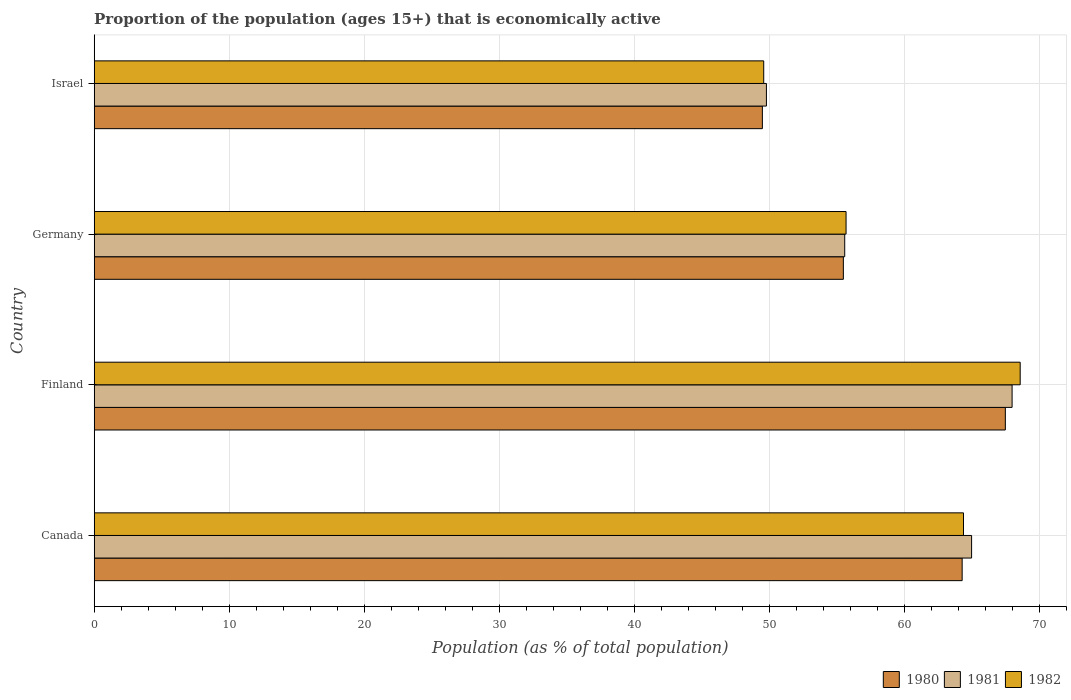How many groups of bars are there?
Your answer should be very brief. 4. How many bars are there on the 4th tick from the top?
Your answer should be compact. 3. How many bars are there on the 1st tick from the bottom?
Your answer should be compact. 3. What is the label of the 1st group of bars from the top?
Provide a succinct answer. Israel. What is the proportion of the population that is economically active in 1981 in Canada?
Ensure brevity in your answer.  65. Across all countries, what is the maximum proportion of the population that is economically active in 1980?
Keep it short and to the point. 67.5. Across all countries, what is the minimum proportion of the population that is economically active in 1980?
Your answer should be compact. 49.5. In which country was the proportion of the population that is economically active in 1982 maximum?
Your answer should be very brief. Finland. In which country was the proportion of the population that is economically active in 1981 minimum?
Your answer should be compact. Israel. What is the total proportion of the population that is economically active in 1980 in the graph?
Make the answer very short. 236.8. What is the difference between the proportion of the population that is economically active in 1982 in Canada and that in Germany?
Offer a terse response. 8.7. What is the difference between the proportion of the population that is economically active in 1982 in Germany and the proportion of the population that is economically active in 1980 in Finland?
Ensure brevity in your answer.  -11.8. What is the average proportion of the population that is economically active in 1982 per country?
Provide a short and direct response. 59.57. What is the difference between the proportion of the population that is economically active in 1981 and proportion of the population that is economically active in 1980 in Israel?
Your answer should be compact. 0.3. In how many countries, is the proportion of the population that is economically active in 1982 greater than 12 %?
Provide a succinct answer. 4. What is the ratio of the proportion of the population that is economically active in 1982 in Finland to that in Germany?
Keep it short and to the point. 1.23. Is the proportion of the population that is economically active in 1980 in Finland less than that in Israel?
Offer a very short reply. No. Is the difference between the proportion of the population that is economically active in 1981 in Finland and Germany greater than the difference between the proportion of the population that is economically active in 1980 in Finland and Germany?
Give a very brief answer. Yes. What is the difference between the highest and the second highest proportion of the population that is economically active in 1980?
Your answer should be compact. 3.2. Is the sum of the proportion of the population that is economically active in 1981 in Finland and Germany greater than the maximum proportion of the population that is economically active in 1982 across all countries?
Provide a short and direct response. Yes. What does the 1st bar from the top in Germany represents?
Give a very brief answer. 1982. What does the 2nd bar from the bottom in Canada represents?
Offer a very short reply. 1981. Are all the bars in the graph horizontal?
Offer a very short reply. Yes. Are the values on the major ticks of X-axis written in scientific E-notation?
Your answer should be very brief. No. Does the graph contain any zero values?
Make the answer very short. No. Does the graph contain grids?
Your answer should be very brief. Yes. Where does the legend appear in the graph?
Ensure brevity in your answer.  Bottom right. What is the title of the graph?
Offer a terse response. Proportion of the population (ages 15+) that is economically active. What is the label or title of the X-axis?
Provide a succinct answer. Population (as % of total population). What is the Population (as % of total population) of 1980 in Canada?
Make the answer very short. 64.3. What is the Population (as % of total population) in 1981 in Canada?
Provide a succinct answer. 65. What is the Population (as % of total population) in 1982 in Canada?
Your answer should be very brief. 64.4. What is the Population (as % of total population) of 1980 in Finland?
Your response must be concise. 67.5. What is the Population (as % of total population) of 1981 in Finland?
Make the answer very short. 68. What is the Population (as % of total population) in 1982 in Finland?
Your answer should be very brief. 68.6. What is the Population (as % of total population) of 1980 in Germany?
Your answer should be compact. 55.5. What is the Population (as % of total population) in 1981 in Germany?
Your answer should be compact. 55.6. What is the Population (as % of total population) of 1982 in Germany?
Keep it short and to the point. 55.7. What is the Population (as % of total population) in 1980 in Israel?
Offer a very short reply. 49.5. What is the Population (as % of total population) of 1981 in Israel?
Offer a very short reply. 49.8. What is the Population (as % of total population) in 1982 in Israel?
Your answer should be very brief. 49.6. Across all countries, what is the maximum Population (as % of total population) of 1980?
Offer a terse response. 67.5. Across all countries, what is the maximum Population (as % of total population) in 1981?
Offer a terse response. 68. Across all countries, what is the maximum Population (as % of total population) in 1982?
Give a very brief answer. 68.6. Across all countries, what is the minimum Population (as % of total population) of 1980?
Offer a terse response. 49.5. Across all countries, what is the minimum Population (as % of total population) of 1981?
Your response must be concise. 49.8. Across all countries, what is the minimum Population (as % of total population) of 1982?
Offer a very short reply. 49.6. What is the total Population (as % of total population) in 1980 in the graph?
Offer a very short reply. 236.8. What is the total Population (as % of total population) of 1981 in the graph?
Provide a succinct answer. 238.4. What is the total Population (as % of total population) of 1982 in the graph?
Your answer should be compact. 238.3. What is the difference between the Population (as % of total population) of 1981 in Canada and that in Finland?
Offer a terse response. -3. What is the difference between the Population (as % of total population) of 1981 in Canada and that in Germany?
Offer a very short reply. 9.4. What is the difference between the Population (as % of total population) of 1980 in Canada and that in Israel?
Provide a succinct answer. 14.8. What is the difference between the Population (as % of total population) in 1981 in Canada and that in Israel?
Offer a very short reply. 15.2. What is the difference between the Population (as % of total population) of 1982 in Finland and that in Germany?
Your answer should be very brief. 12.9. What is the difference between the Population (as % of total population) of 1981 in Finland and that in Israel?
Offer a terse response. 18.2. What is the difference between the Population (as % of total population) of 1980 in Germany and that in Israel?
Make the answer very short. 6. What is the difference between the Population (as % of total population) of 1981 in Germany and that in Israel?
Offer a terse response. 5.8. What is the difference between the Population (as % of total population) of 1980 in Canada and the Population (as % of total population) of 1981 in Finland?
Offer a terse response. -3.7. What is the difference between the Population (as % of total population) in 1980 in Canada and the Population (as % of total population) in 1981 in Germany?
Ensure brevity in your answer.  8.7. What is the difference between the Population (as % of total population) of 1981 in Canada and the Population (as % of total population) of 1982 in Germany?
Keep it short and to the point. 9.3. What is the difference between the Population (as % of total population) in 1980 in Canada and the Population (as % of total population) in 1981 in Israel?
Offer a very short reply. 14.5. What is the difference between the Population (as % of total population) in 1980 in Canada and the Population (as % of total population) in 1982 in Israel?
Keep it short and to the point. 14.7. What is the difference between the Population (as % of total population) of 1981 in Canada and the Population (as % of total population) of 1982 in Israel?
Offer a terse response. 15.4. What is the difference between the Population (as % of total population) of 1980 in Finland and the Population (as % of total population) of 1981 in Germany?
Make the answer very short. 11.9. What is the difference between the Population (as % of total population) of 1980 in Finland and the Population (as % of total population) of 1982 in Germany?
Ensure brevity in your answer.  11.8. What is the difference between the Population (as % of total population) of 1981 in Finland and the Population (as % of total population) of 1982 in Germany?
Offer a terse response. 12.3. What is the difference between the Population (as % of total population) of 1981 in Finland and the Population (as % of total population) of 1982 in Israel?
Your answer should be very brief. 18.4. What is the difference between the Population (as % of total population) in 1980 in Germany and the Population (as % of total population) in 1982 in Israel?
Offer a very short reply. 5.9. What is the difference between the Population (as % of total population) in 1981 in Germany and the Population (as % of total population) in 1982 in Israel?
Offer a terse response. 6. What is the average Population (as % of total population) of 1980 per country?
Provide a succinct answer. 59.2. What is the average Population (as % of total population) of 1981 per country?
Your answer should be compact. 59.6. What is the average Population (as % of total population) of 1982 per country?
Provide a short and direct response. 59.58. What is the difference between the Population (as % of total population) of 1980 and Population (as % of total population) of 1982 in Finland?
Provide a short and direct response. -1.1. What is the difference between the Population (as % of total population) in 1981 and Population (as % of total population) in 1982 in Finland?
Provide a succinct answer. -0.6. What is the difference between the Population (as % of total population) of 1980 and Population (as % of total population) of 1981 in Germany?
Your response must be concise. -0.1. What is the difference between the Population (as % of total population) of 1980 and Population (as % of total population) of 1981 in Israel?
Give a very brief answer. -0.3. What is the ratio of the Population (as % of total population) of 1980 in Canada to that in Finland?
Ensure brevity in your answer.  0.95. What is the ratio of the Population (as % of total population) of 1981 in Canada to that in Finland?
Give a very brief answer. 0.96. What is the ratio of the Population (as % of total population) of 1982 in Canada to that in Finland?
Offer a very short reply. 0.94. What is the ratio of the Population (as % of total population) in 1980 in Canada to that in Germany?
Your answer should be compact. 1.16. What is the ratio of the Population (as % of total population) of 1981 in Canada to that in Germany?
Provide a short and direct response. 1.17. What is the ratio of the Population (as % of total population) of 1982 in Canada to that in Germany?
Give a very brief answer. 1.16. What is the ratio of the Population (as % of total population) in 1980 in Canada to that in Israel?
Your answer should be compact. 1.3. What is the ratio of the Population (as % of total population) of 1981 in Canada to that in Israel?
Make the answer very short. 1.31. What is the ratio of the Population (as % of total population) of 1982 in Canada to that in Israel?
Your response must be concise. 1.3. What is the ratio of the Population (as % of total population) of 1980 in Finland to that in Germany?
Provide a succinct answer. 1.22. What is the ratio of the Population (as % of total population) of 1981 in Finland to that in Germany?
Your response must be concise. 1.22. What is the ratio of the Population (as % of total population) of 1982 in Finland to that in Germany?
Keep it short and to the point. 1.23. What is the ratio of the Population (as % of total population) in 1980 in Finland to that in Israel?
Make the answer very short. 1.36. What is the ratio of the Population (as % of total population) in 1981 in Finland to that in Israel?
Give a very brief answer. 1.37. What is the ratio of the Population (as % of total population) in 1982 in Finland to that in Israel?
Provide a short and direct response. 1.38. What is the ratio of the Population (as % of total population) of 1980 in Germany to that in Israel?
Provide a succinct answer. 1.12. What is the ratio of the Population (as % of total population) in 1981 in Germany to that in Israel?
Keep it short and to the point. 1.12. What is the ratio of the Population (as % of total population) of 1982 in Germany to that in Israel?
Your response must be concise. 1.12. What is the difference between the highest and the second highest Population (as % of total population) in 1982?
Provide a short and direct response. 4.2. What is the difference between the highest and the lowest Population (as % of total population) in 1980?
Ensure brevity in your answer.  18. What is the difference between the highest and the lowest Population (as % of total population) in 1981?
Make the answer very short. 18.2. What is the difference between the highest and the lowest Population (as % of total population) of 1982?
Give a very brief answer. 19. 